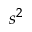Convert formula to latex. <formula><loc_0><loc_0><loc_500><loc_500>s ^ { 2 }</formula> 